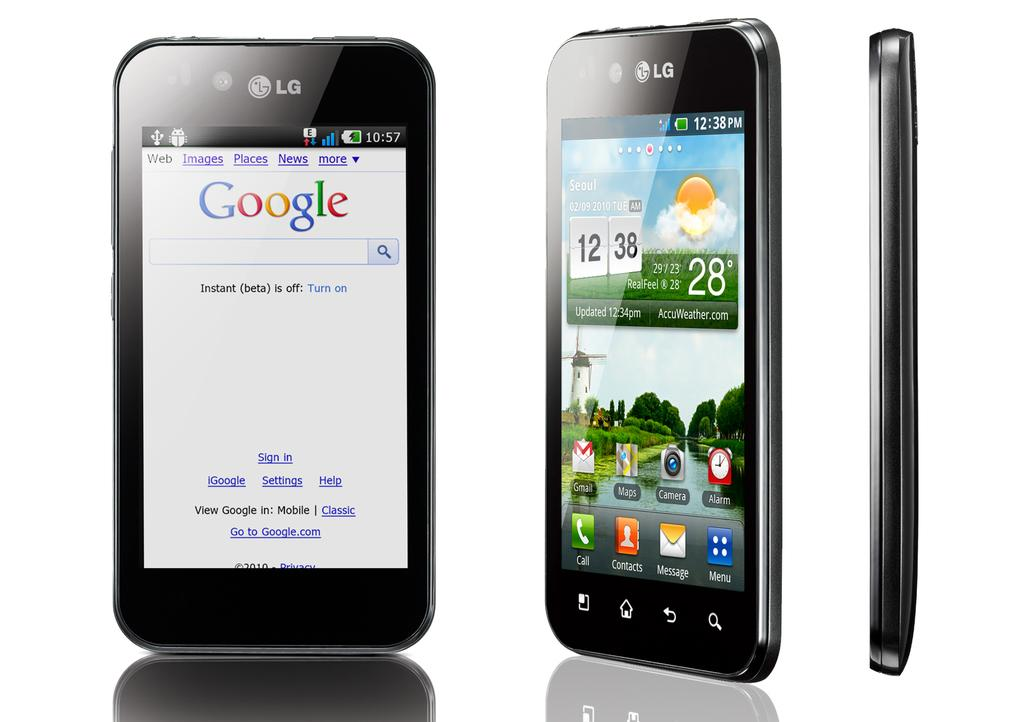<image>
Give a short and clear explanation of the subsequent image. An LG phone shown from different angles, one with the Google screen on it. 